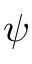Convert formula to latex. <formula><loc_0><loc_0><loc_500><loc_500>\psi</formula> 